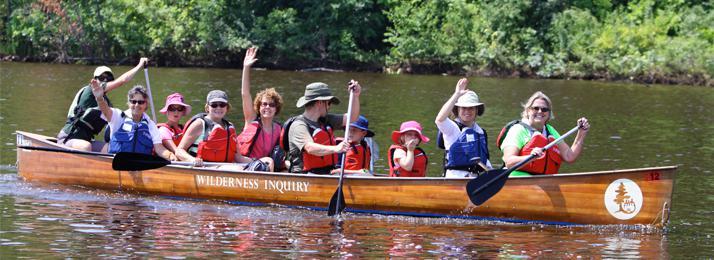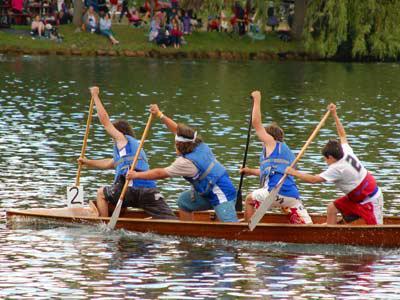The first image is the image on the left, the second image is the image on the right. Given the left and right images, does the statement "The left image features one light brown canoe with a white circle on its front, heading rightward with at least six people sitting in it." hold true? Answer yes or no. Yes. The first image is the image on the left, the second image is the image on the right. Analyze the images presented: Is the assertion "The left and right image contains the same number of boats." valid? Answer yes or no. Yes. 